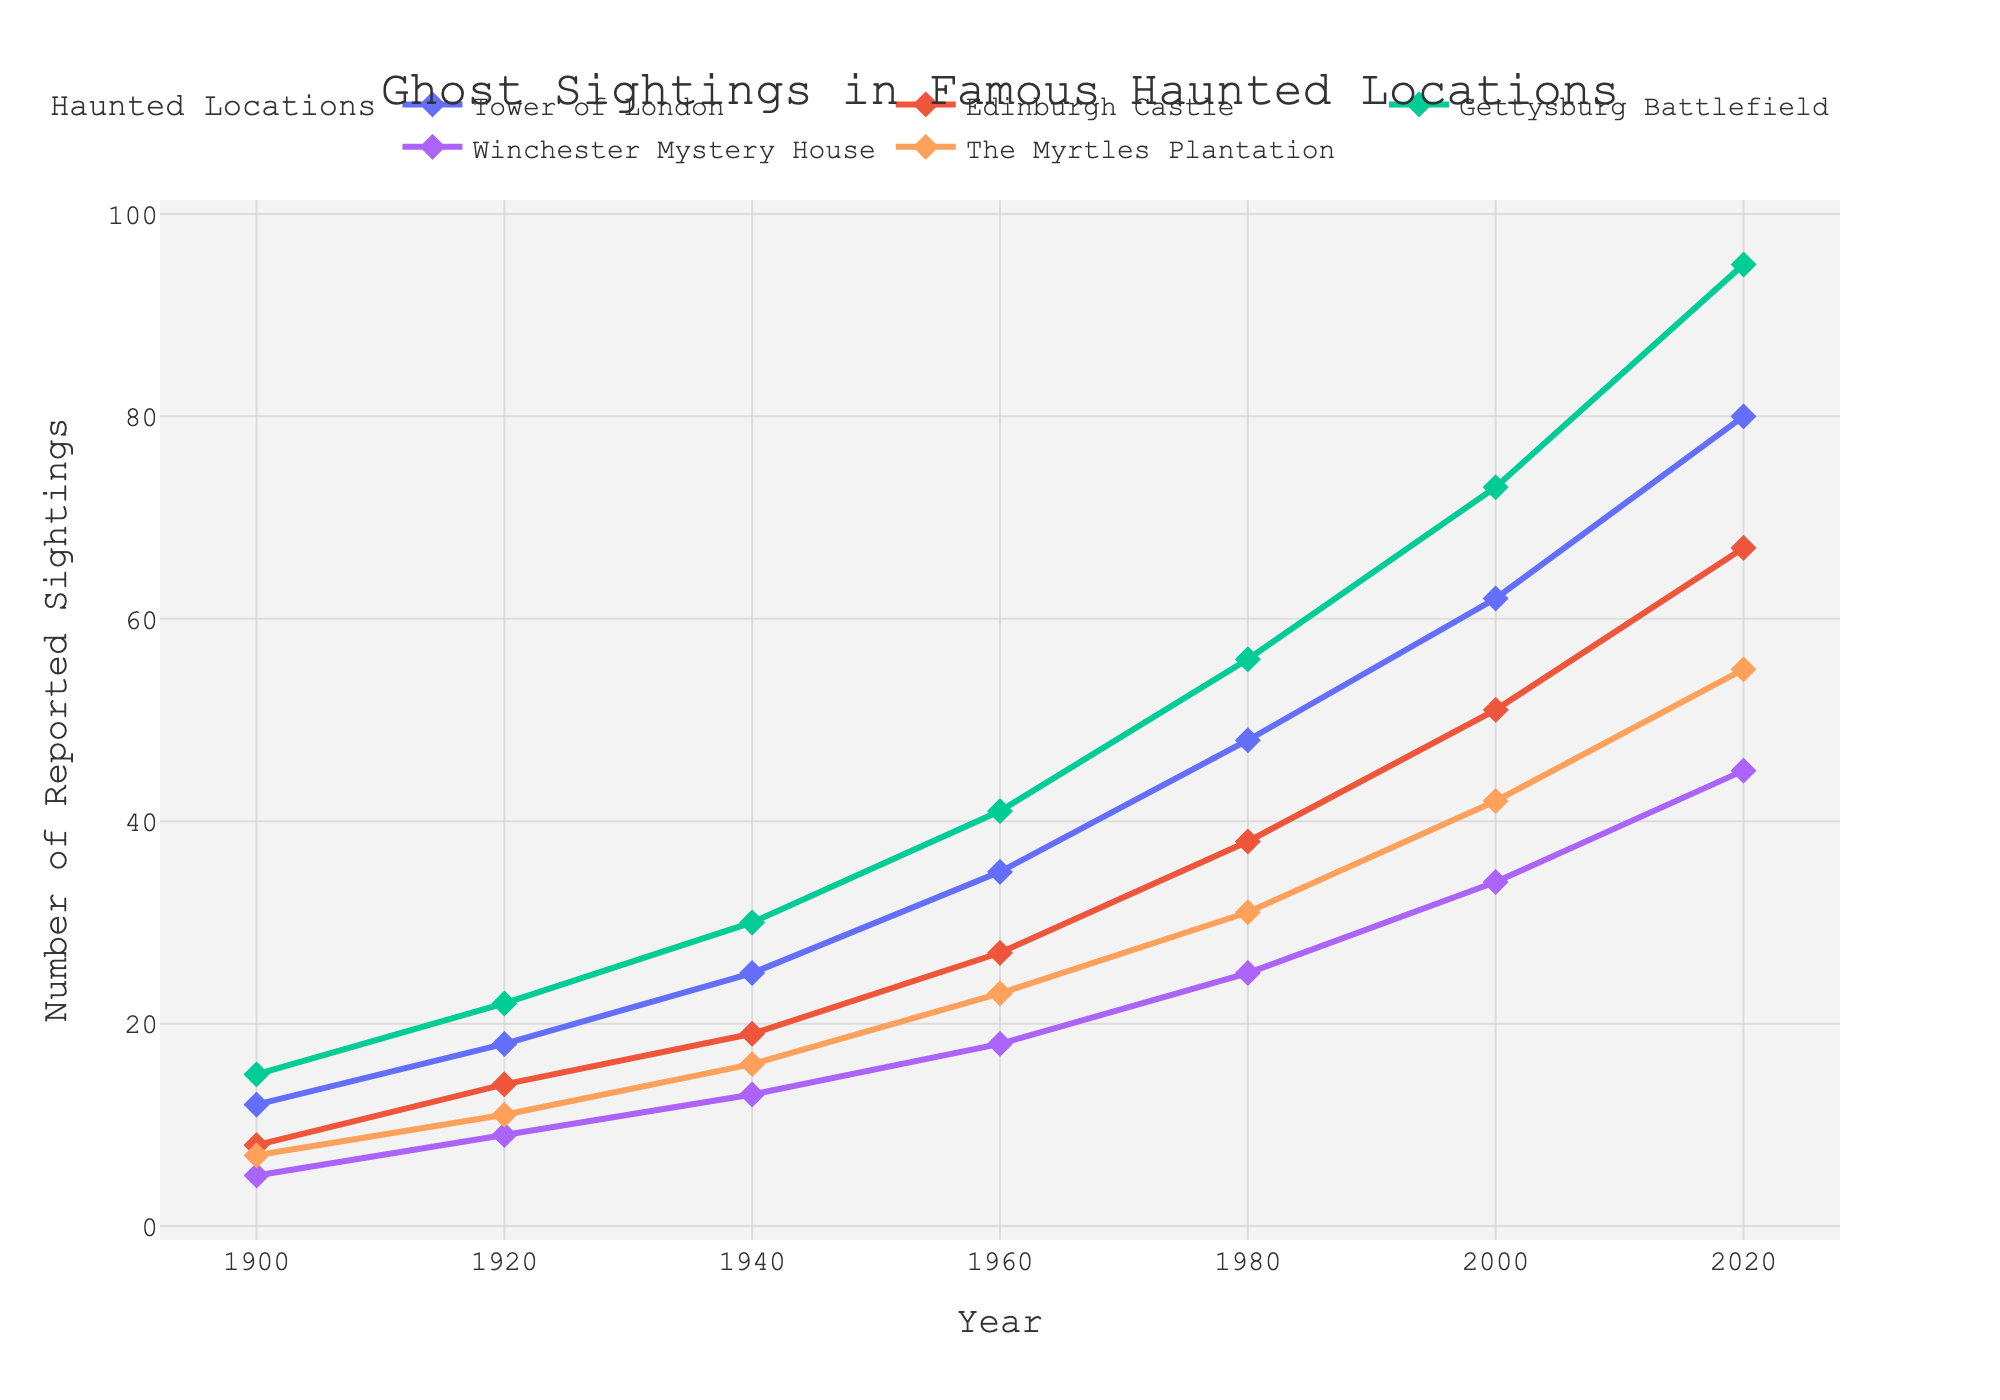What is the highest number of reported ghost sightings recorded at the Tower of London? The highest number of reported ghost sightings at the Tower of London can be seen at the farthest right point on the Tower of London's line in the plot. This point corresponds to the year 2020.
Answer: 80 Between 1940 and 1960, which location saw the largest increase in reported ghost sightings? To determine which location saw the largest increase, we subtract the 1940 value from the 1960 value for each location: Tower of London (35 - 25 = 10), Edinburgh Castle (27 - 19 = 8), Gettysburg Battlefield (41 - 30 = 11), Winchester Mystery House (18 - 13 = 5), The Myrtles Plantation (23 - 16 = 7).
Answer: Gettysburg Battlefield How does the frequency of reported ghost sightings at Winchester Mystery House in 2000 compare to that at The Myrtles Plantation in the same year? In 2000, the Winchester Mystery House had 34 reported ghost sightings while The Myrtles Plantation had 42.
Answer: The Myrtles Plantation had more sightings What is the overall trend in ghost sightings from 1900 to 2020 for all locations? By observing the lines for each location from left to right, all lines show a general upward trend, indicating an increase in the number of reported ghost sightings over time.
Answer: Increasing Which location experienced the smallest change in reported ghost sightings between 1920 and 1940? We calculate the difference between 1920 and 1940 for each location: Tower of London (25 - 18 = 7), Edinburgh Castle (19 - 14 = 5), Gettysburg Battlefield (30 - 22 = 8), Winchester Mystery House (13 - 9 = 4), The Myrtles Plantation (16 - 11 = 5).
Answer: Winchester Mystery House What is the average number of reported ghost sightings at Gettysburg Battlefield from 1900 to 2020? Add the sightings at Gettysburg Battlefield for each year and divide by the number of years: (15 + 22 + 30 + 41 + 56 + 73 + 95) / 7 = 46.
Answer: 46 Which two locations have the closest number of sightings in 1980? Compare the sighting numbers in 1980: Tower of London (48), Edinburgh Castle (38), Gettysburg Battlefield (56), Winchester Mystery House (25), The Myrtles Plantation (31). The closest pairs are Winchester Mystery House and The Myrtles Plantation (difference of 6).
Answer: Winchester Mystery House and The Myrtles Plantation In 2020, what is the total number of reported ghost sightings across all locations? Sum the sightings at each location in 2020: 80 (Tower of London) + 67 (Edinburgh Castle) + 95 (Gettysburg Battlefield) + 45 (Winchester Mystery House) + 55 (The Myrtles Plantation) = 342.
Answer: 342 Which location had the highest growth in reported ghost sightings from 1900 to 2000? Subtract the 1900 value from the 2000 value for each location: Tower of London (62 - 12 = 50), Edinburgh Castle (51 - 8 = 43), Gettysburg Battlefield (73 - 15 = 58), Winchester Mystery House (34 - 5 = 29), The Myrtles Plantation (42 - 7 = 35).
Answer: Gettysburg Battlefield 